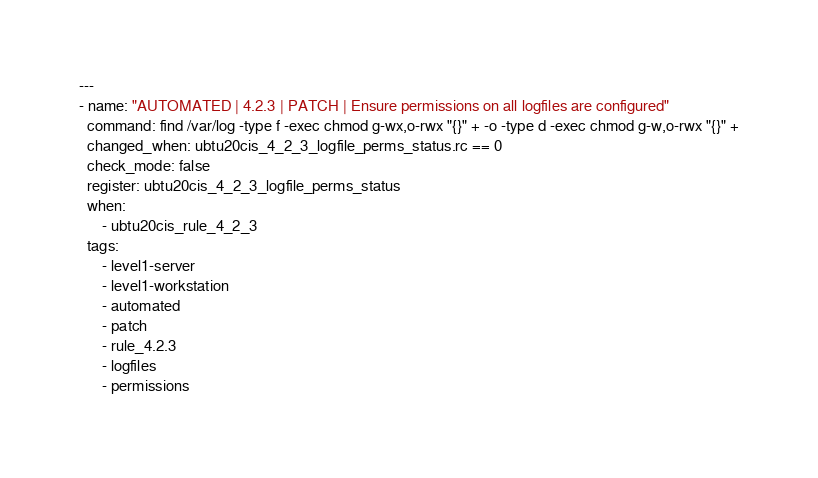<code> <loc_0><loc_0><loc_500><loc_500><_YAML_>---
- name: "AUTOMATED | 4.2.3 | PATCH | Ensure permissions on all logfiles are configured"
  command: find /var/log -type f -exec chmod g-wx,o-rwx "{}" + -o -type d -exec chmod g-w,o-rwx "{}" +
  changed_when: ubtu20cis_4_2_3_logfile_perms_status.rc == 0
  check_mode: false
  register: ubtu20cis_4_2_3_logfile_perms_status
  when:
      - ubtu20cis_rule_4_2_3
  tags:
      - level1-server
      - level1-workstation
      - automated
      - patch
      - rule_4.2.3
      - logfiles
      - permissions
</code> 